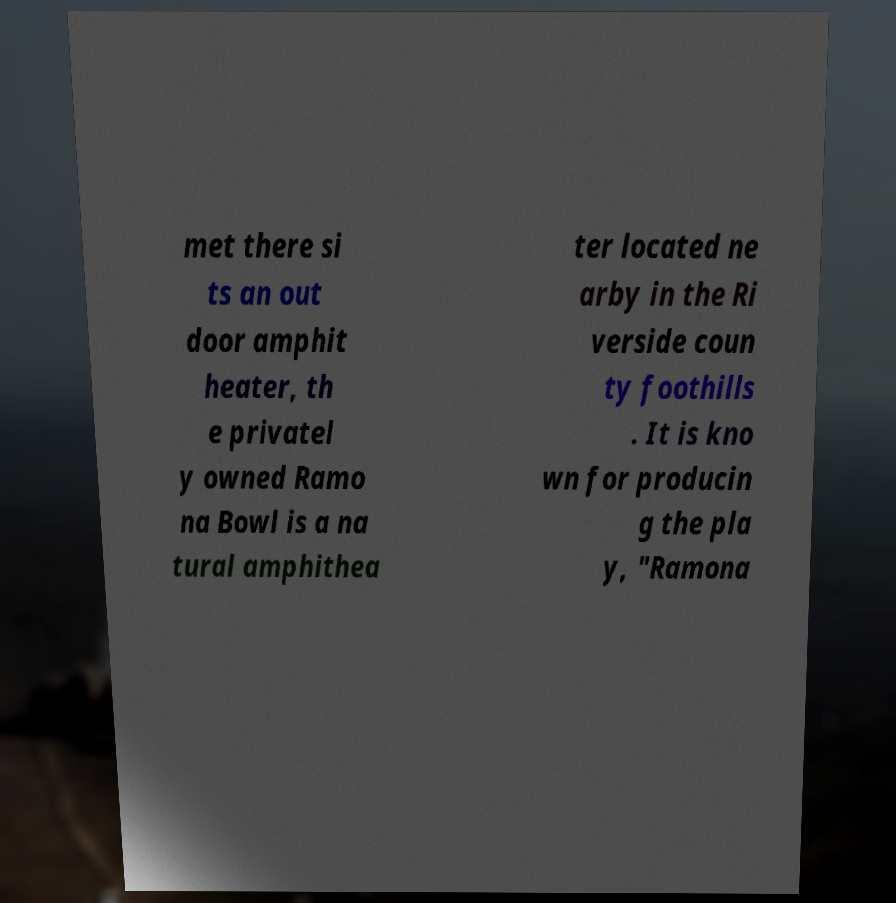Could you extract and type out the text from this image? met there si ts an out door amphit heater, th e privatel y owned Ramo na Bowl is a na tural amphithea ter located ne arby in the Ri verside coun ty foothills . It is kno wn for producin g the pla y, "Ramona 